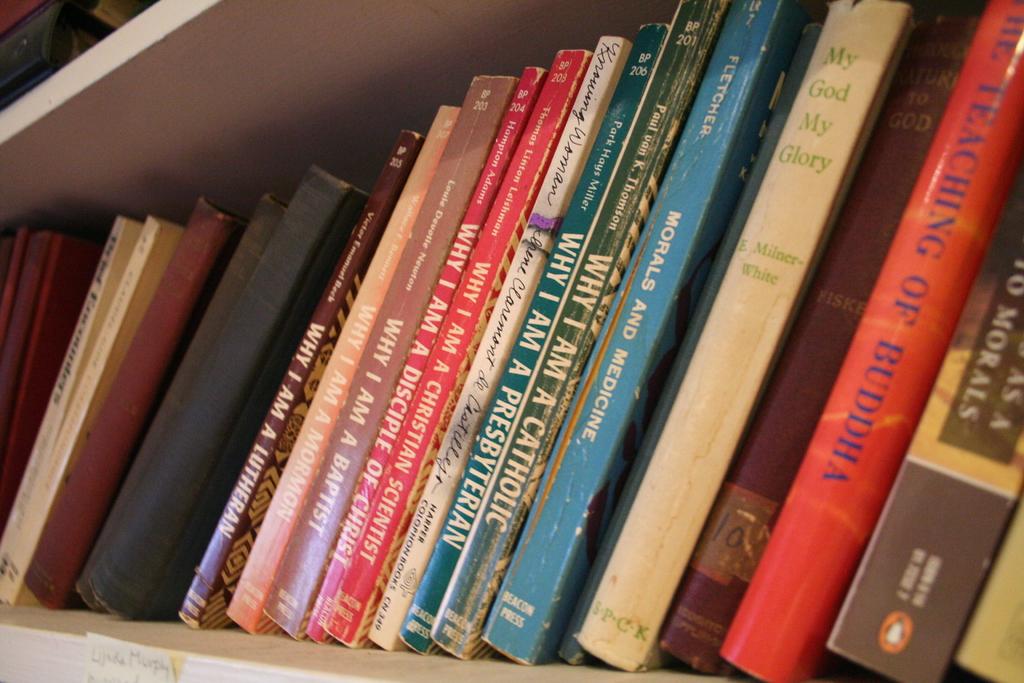What is the title of one of the books shown here?
Provide a succinct answer. Why i am a catholic. What is the blue book?
Offer a very short reply. Morals and medicine. 